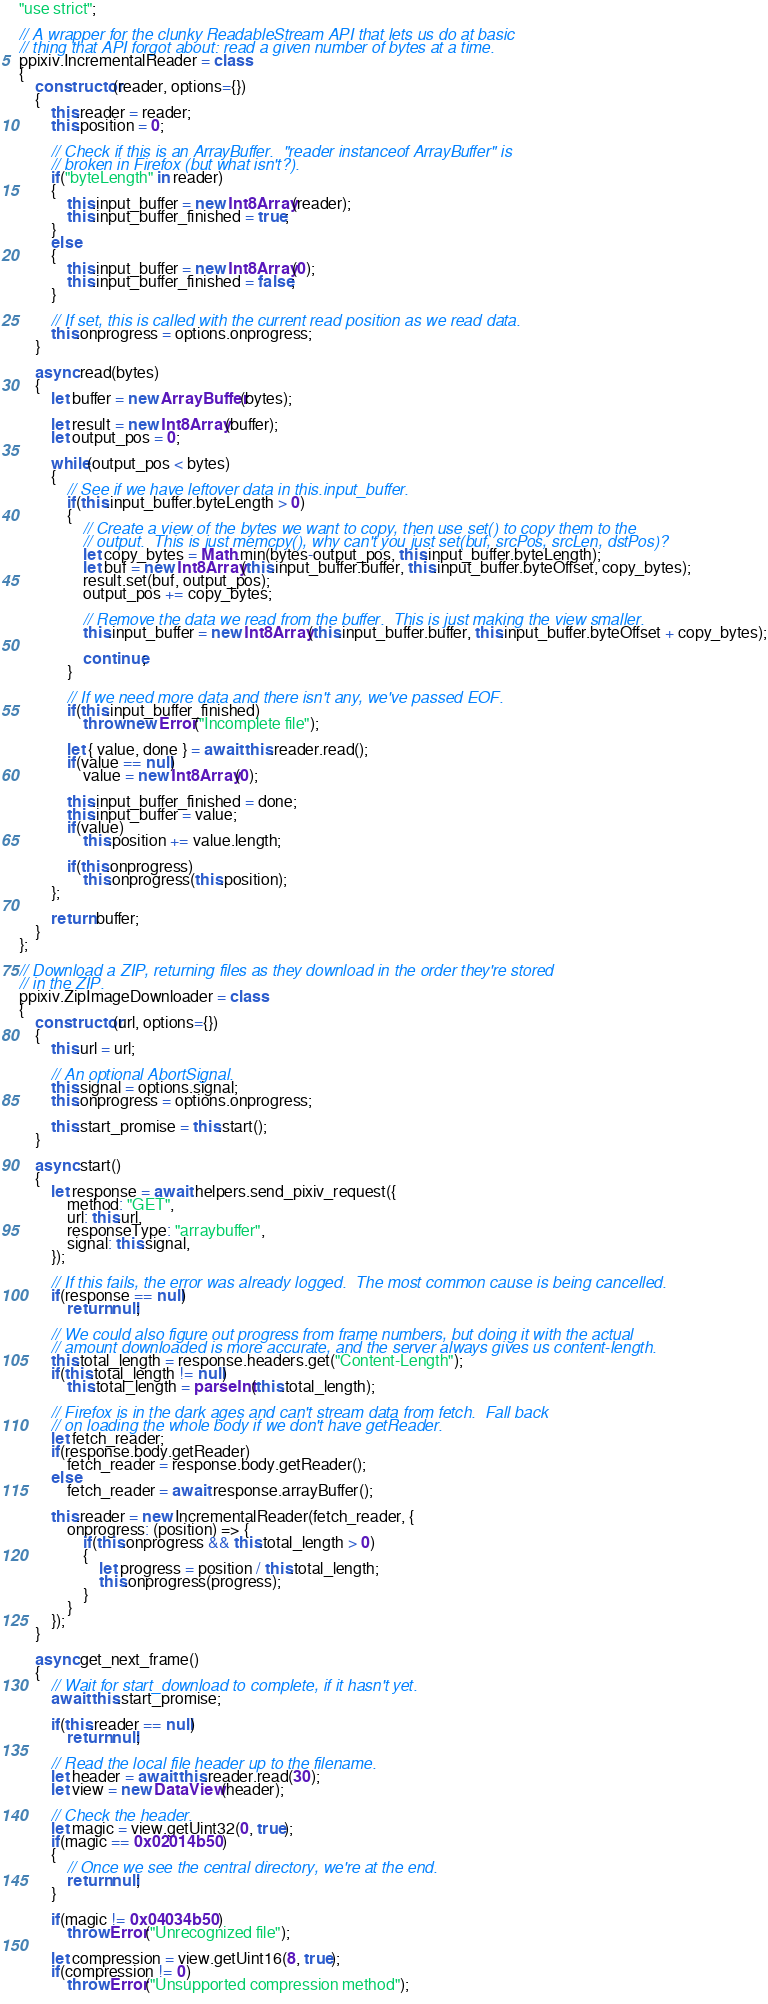Convert code to text. <code><loc_0><loc_0><loc_500><loc_500><_JavaScript_>"use strict";

// A wrapper for the clunky ReadableStream API that lets us do at basic
// thing that API forgot about: read a given number of bytes at a time.
ppixiv.IncrementalReader = class
{
    constructor(reader, options={})
    {
        this.reader = reader;
        this.position = 0;

        // Check if this is an ArrayBuffer.  "reader instanceof ArrayBuffer" is
        // broken in Firefox (but what isn't?).
        if("byteLength" in reader)
        {
            this.input_buffer = new Int8Array(reader);
            this.input_buffer_finished = true;
        }
        else
        {
            this.input_buffer = new Int8Array(0);
            this.input_buffer_finished = false;
        }

        // If set, this is called with the current read position as we read data.
        this.onprogress = options.onprogress;
    }

    async read(bytes)
    {
        let buffer = new ArrayBuffer(bytes);

        let result = new Int8Array(buffer);
        let output_pos = 0;

        while(output_pos < bytes)
        {
            // See if we have leftover data in this.input_buffer.
            if(this.input_buffer.byteLength > 0)
            {
                // Create a view of the bytes we want to copy, then use set() to copy them to the
                // output.  This is just memcpy(), why can't you just set(buf, srcPos, srcLen, dstPos)?
                let copy_bytes = Math.min(bytes-output_pos, this.input_buffer.byteLength);
                let buf = new Int8Array(this.input_buffer.buffer, this.input_buffer.byteOffset, copy_bytes);
                result.set(buf, output_pos);
                output_pos += copy_bytes;

                // Remove the data we read from the buffer.  This is just making the view smaller.
                this.input_buffer = new Int8Array(this.input_buffer.buffer, this.input_buffer.byteOffset + copy_bytes);

                continue;
            }

            // If we need more data and there isn't any, we've passed EOF.
            if(this.input_buffer_finished)
                throw new Error("Incomplete file");

            let { value, done } = await this.reader.read();
            if(value == null)
                value = new Int8Array(0);

            this.input_buffer_finished = done;
            this.input_buffer = value;
            if(value)
                this.position += value.length;

            if(this.onprogress)
                this.onprogress(this.position);
        };

        return buffer;
    }
};

// Download a ZIP, returning files as they download in the order they're stored
// in the ZIP.
ppixiv.ZipImageDownloader = class
{
    constructor(url, options={})
    {
        this.url = url;

        // An optional AbortSignal.
        this.signal = options.signal;
        this.onprogress = options.onprogress;

        this.start_promise = this.start();
    }

    async start()
    {
        let response = await helpers.send_pixiv_request({
            method: "GET",
            url: this.url,
            responseType: "arraybuffer",
            signal: this.signal,
        });        

        // If this fails, the error was already logged.  The most common cause is being cancelled.
        if(response == null)
            return null;

        // We could also figure out progress from frame numbers, but doing it with the actual
        // amount downloaded is more accurate, and the server always gives us content-length.
        this.total_length = response.headers.get("Content-Length");
        if(this.total_length != null)
            this.total_length = parseInt(this.total_length);

        // Firefox is in the dark ages and can't stream data from fetch.  Fall back
        // on loading the whole body if we don't have getReader.
        let fetch_reader;
        if(response.body.getReader)
            fetch_reader = response.body.getReader();
        else
            fetch_reader = await response.arrayBuffer();

        this.reader = new IncrementalReader(fetch_reader, {
            onprogress: (position) => {
                if(this.onprogress && this.total_length > 0)
                {
                    let progress = position / this.total_length;
                    this.onprogress(progress);
                }
            }
        });
    }

    async get_next_frame()
    {
        // Wait for start_download to complete, if it hasn't yet.
        await this.start_promise;

        if(this.reader == null)
            return null;
        
        // Read the local file header up to the filename.
        let header = await this.reader.read(30);
        let view = new DataView(header);

        // Check the header.
        let magic = view.getUint32(0, true);
        if(magic == 0x02014b50)
        {
            // Once we see the central directory, we're at the end.
            return null;
        }

        if(magic != 0x04034b50)
            throw Error("Unrecognized file");

        let compression = view.getUint16(8, true);
        if(compression != 0)
            throw Error("Unsupported compression method");
        </code> 